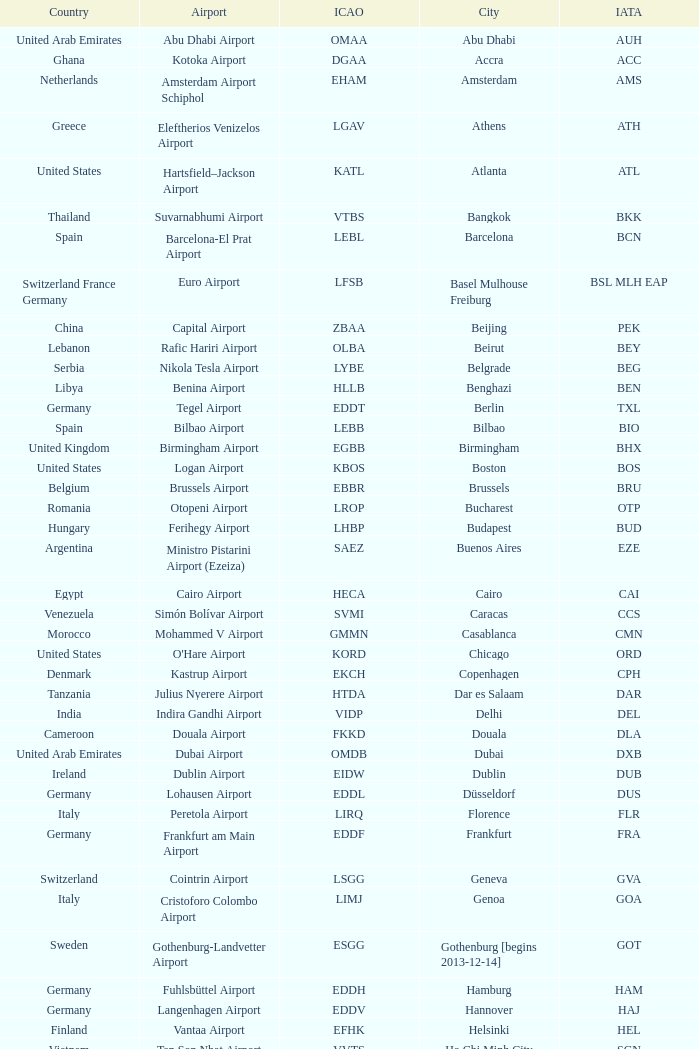What is the ICAO of Douala city? FKKD. 